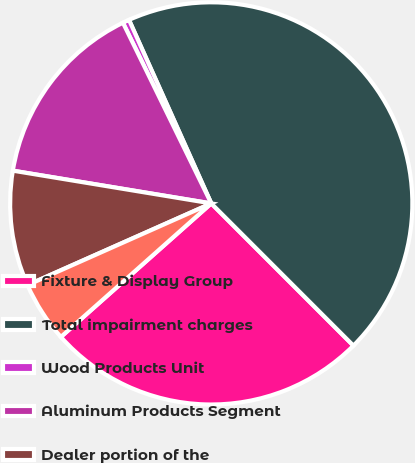<chart> <loc_0><loc_0><loc_500><loc_500><pie_chart><fcel>Fixture & Display Group<fcel>Total impairment charges<fcel>Wood Products Unit<fcel>Aluminum Products Segment<fcel>Dealer portion of the<fcel>An automotive seating<nl><fcel>25.94%<fcel>44.21%<fcel>0.53%<fcel>15.16%<fcel>9.26%<fcel>4.9%<nl></chart> 